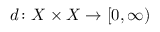<formula> <loc_0><loc_0><loc_500><loc_500>d \colon X \times X \to [ 0 , \infty )</formula> 